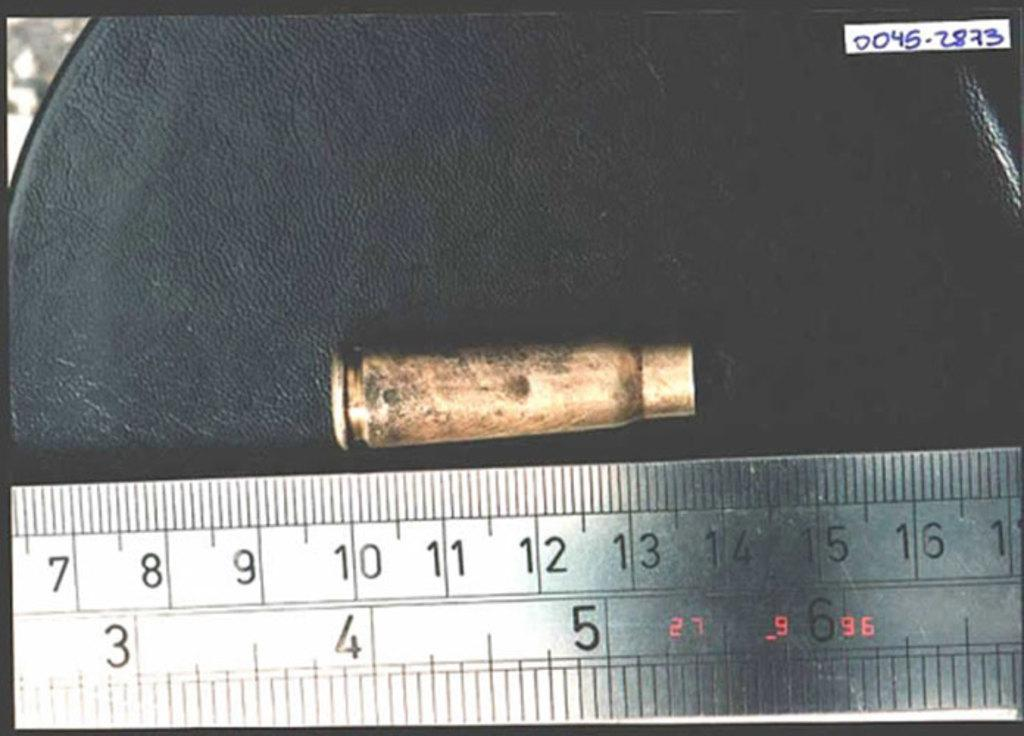<image>
Create a compact narrative representing the image presented. A bullet casing sits above the numbers 10-14 on a ruler 